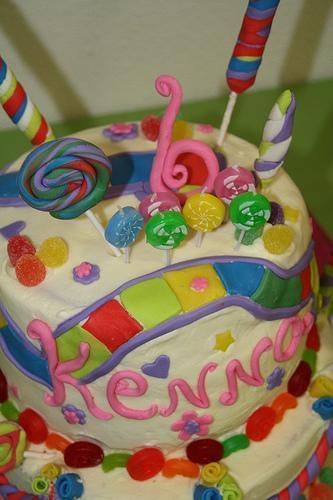How many cakes are there?
Give a very brief answer. 1. How many of the small round candles are green?
Give a very brief answer. 2. 